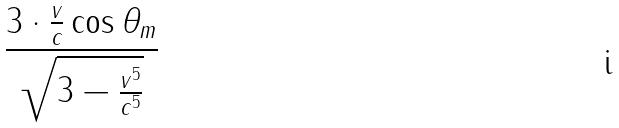Convert formula to latex. <formula><loc_0><loc_0><loc_500><loc_500>\frac { 3 \cdot \frac { v } { c } \cos \theta _ { m } } { \sqrt { 3 - \frac { v ^ { 5 } } { c ^ { 5 } } } }</formula> 